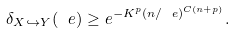<formula> <loc_0><loc_0><loc_500><loc_500>\delta _ { X \hookrightarrow Y } ( \ e ) \geq e ^ { - K ^ { p } ( n / \ e ) ^ { C ( n + p ) } } .</formula> 